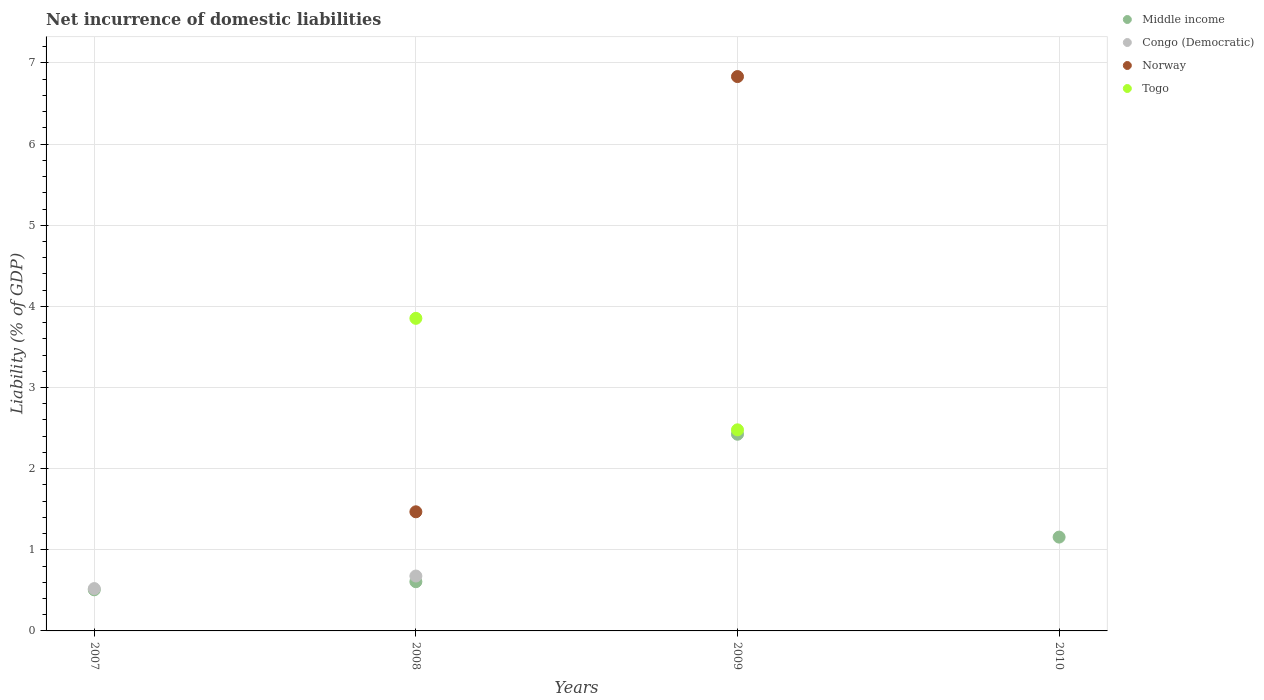How many different coloured dotlines are there?
Offer a terse response. 4. What is the net incurrence of domestic liabilities in Norway in 2008?
Offer a very short reply. 1.47. Across all years, what is the maximum net incurrence of domestic liabilities in Middle income?
Offer a very short reply. 2.42. Across all years, what is the minimum net incurrence of domestic liabilities in Congo (Democratic)?
Offer a terse response. 0. What is the total net incurrence of domestic liabilities in Norway in the graph?
Offer a very short reply. 8.3. What is the difference between the net incurrence of domestic liabilities in Middle income in 2008 and that in 2009?
Your answer should be very brief. -1.82. What is the difference between the net incurrence of domestic liabilities in Norway in 2007 and the net incurrence of domestic liabilities in Middle income in 2008?
Make the answer very short. -0.61. What is the average net incurrence of domestic liabilities in Togo per year?
Your answer should be compact. 1.58. In the year 2007, what is the difference between the net incurrence of domestic liabilities in Middle income and net incurrence of domestic liabilities in Congo (Democratic)?
Make the answer very short. -0.02. In how many years, is the net incurrence of domestic liabilities in Congo (Democratic) greater than 4.4 %?
Give a very brief answer. 0. Is the difference between the net incurrence of domestic liabilities in Middle income in 2007 and 2008 greater than the difference between the net incurrence of domestic liabilities in Congo (Democratic) in 2007 and 2008?
Ensure brevity in your answer.  Yes. What is the difference between the highest and the second highest net incurrence of domestic liabilities in Middle income?
Ensure brevity in your answer.  1.27. What is the difference between the highest and the lowest net incurrence of domestic liabilities in Norway?
Your answer should be very brief. 6.83. Is it the case that in every year, the sum of the net incurrence of domestic liabilities in Middle income and net incurrence of domestic liabilities in Congo (Democratic)  is greater than the net incurrence of domestic liabilities in Togo?
Ensure brevity in your answer.  No. Is the net incurrence of domestic liabilities in Congo (Democratic) strictly greater than the net incurrence of domestic liabilities in Togo over the years?
Keep it short and to the point. No. Is the net incurrence of domestic liabilities in Middle income strictly less than the net incurrence of domestic liabilities in Norway over the years?
Keep it short and to the point. No. How many dotlines are there?
Ensure brevity in your answer.  4. How many years are there in the graph?
Your answer should be compact. 4. What is the difference between two consecutive major ticks on the Y-axis?
Your answer should be compact. 1. Are the values on the major ticks of Y-axis written in scientific E-notation?
Your answer should be compact. No. How are the legend labels stacked?
Provide a short and direct response. Vertical. What is the title of the graph?
Keep it short and to the point. Net incurrence of domestic liabilities. Does "Palau" appear as one of the legend labels in the graph?
Offer a terse response. No. What is the label or title of the Y-axis?
Your answer should be compact. Liability (% of GDP). What is the Liability (% of GDP) in Middle income in 2007?
Ensure brevity in your answer.  0.51. What is the Liability (% of GDP) in Congo (Democratic) in 2007?
Your answer should be very brief. 0.52. What is the Liability (% of GDP) in Norway in 2007?
Offer a terse response. 0. What is the Liability (% of GDP) in Togo in 2007?
Give a very brief answer. 0. What is the Liability (% of GDP) of Middle income in 2008?
Keep it short and to the point. 0.61. What is the Liability (% of GDP) of Congo (Democratic) in 2008?
Give a very brief answer. 0.68. What is the Liability (% of GDP) of Norway in 2008?
Give a very brief answer. 1.47. What is the Liability (% of GDP) of Togo in 2008?
Ensure brevity in your answer.  3.85. What is the Liability (% of GDP) in Middle income in 2009?
Provide a short and direct response. 2.42. What is the Liability (% of GDP) in Congo (Democratic) in 2009?
Provide a short and direct response. 0. What is the Liability (% of GDP) of Norway in 2009?
Provide a succinct answer. 6.83. What is the Liability (% of GDP) in Togo in 2009?
Your response must be concise. 2.48. What is the Liability (% of GDP) in Middle income in 2010?
Keep it short and to the point. 1.16. Across all years, what is the maximum Liability (% of GDP) of Middle income?
Keep it short and to the point. 2.42. Across all years, what is the maximum Liability (% of GDP) in Congo (Democratic)?
Offer a very short reply. 0.68. Across all years, what is the maximum Liability (% of GDP) in Norway?
Give a very brief answer. 6.83. Across all years, what is the maximum Liability (% of GDP) of Togo?
Provide a short and direct response. 3.85. Across all years, what is the minimum Liability (% of GDP) in Middle income?
Keep it short and to the point. 0.51. Across all years, what is the minimum Liability (% of GDP) in Norway?
Your answer should be compact. 0. What is the total Liability (% of GDP) in Middle income in the graph?
Make the answer very short. 4.69. What is the total Liability (% of GDP) in Congo (Democratic) in the graph?
Offer a very short reply. 1.2. What is the total Liability (% of GDP) of Norway in the graph?
Make the answer very short. 8.3. What is the total Liability (% of GDP) of Togo in the graph?
Make the answer very short. 6.33. What is the difference between the Liability (% of GDP) in Middle income in 2007 and that in 2008?
Make the answer very short. -0.1. What is the difference between the Liability (% of GDP) in Congo (Democratic) in 2007 and that in 2008?
Your answer should be very brief. -0.15. What is the difference between the Liability (% of GDP) of Middle income in 2007 and that in 2009?
Provide a succinct answer. -1.92. What is the difference between the Liability (% of GDP) in Middle income in 2007 and that in 2010?
Your answer should be compact. -0.65. What is the difference between the Liability (% of GDP) of Middle income in 2008 and that in 2009?
Offer a very short reply. -1.82. What is the difference between the Liability (% of GDP) of Norway in 2008 and that in 2009?
Provide a short and direct response. -5.36. What is the difference between the Liability (% of GDP) of Togo in 2008 and that in 2009?
Provide a short and direct response. 1.37. What is the difference between the Liability (% of GDP) in Middle income in 2008 and that in 2010?
Your response must be concise. -0.55. What is the difference between the Liability (% of GDP) in Middle income in 2009 and that in 2010?
Your answer should be compact. 1.27. What is the difference between the Liability (% of GDP) of Middle income in 2007 and the Liability (% of GDP) of Congo (Democratic) in 2008?
Ensure brevity in your answer.  -0.17. What is the difference between the Liability (% of GDP) in Middle income in 2007 and the Liability (% of GDP) in Norway in 2008?
Your response must be concise. -0.96. What is the difference between the Liability (% of GDP) in Middle income in 2007 and the Liability (% of GDP) in Togo in 2008?
Keep it short and to the point. -3.35. What is the difference between the Liability (% of GDP) in Congo (Democratic) in 2007 and the Liability (% of GDP) in Norway in 2008?
Provide a succinct answer. -0.95. What is the difference between the Liability (% of GDP) of Congo (Democratic) in 2007 and the Liability (% of GDP) of Togo in 2008?
Provide a short and direct response. -3.33. What is the difference between the Liability (% of GDP) of Middle income in 2007 and the Liability (% of GDP) of Norway in 2009?
Your answer should be very brief. -6.33. What is the difference between the Liability (% of GDP) of Middle income in 2007 and the Liability (% of GDP) of Togo in 2009?
Provide a succinct answer. -1.97. What is the difference between the Liability (% of GDP) in Congo (Democratic) in 2007 and the Liability (% of GDP) in Norway in 2009?
Offer a very short reply. -6.31. What is the difference between the Liability (% of GDP) in Congo (Democratic) in 2007 and the Liability (% of GDP) in Togo in 2009?
Provide a short and direct response. -1.96. What is the difference between the Liability (% of GDP) of Middle income in 2008 and the Liability (% of GDP) of Norway in 2009?
Make the answer very short. -6.23. What is the difference between the Liability (% of GDP) of Middle income in 2008 and the Liability (% of GDP) of Togo in 2009?
Offer a very short reply. -1.87. What is the difference between the Liability (% of GDP) of Congo (Democratic) in 2008 and the Liability (% of GDP) of Norway in 2009?
Offer a very short reply. -6.16. What is the difference between the Liability (% of GDP) in Congo (Democratic) in 2008 and the Liability (% of GDP) in Togo in 2009?
Keep it short and to the point. -1.8. What is the difference between the Liability (% of GDP) in Norway in 2008 and the Liability (% of GDP) in Togo in 2009?
Offer a very short reply. -1.01. What is the average Liability (% of GDP) in Middle income per year?
Your response must be concise. 1.17. What is the average Liability (% of GDP) of Congo (Democratic) per year?
Your answer should be very brief. 0.3. What is the average Liability (% of GDP) of Norway per year?
Keep it short and to the point. 2.08. What is the average Liability (% of GDP) in Togo per year?
Provide a succinct answer. 1.58. In the year 2007, what is the difference between the Liability (% of GDP) of Middle income and Liability (% of GDP) of Congo (Democratic)?
Offer a very short reply. -0.01. In the year 2008, what is the difference between the Liability (% of GDP) of Middle income and Liability (% of GDP) of Congo (Democratic)?
Your answer should be compact. -0.07. In the year 2008, what is the difference between the Liability (% of GDP) in Middle income and Liability (% of GDP) in Norway?
Provide a succinct answer. -0.86. In the year 2008, what is the difference between the Liability (% of GDP) in Middle income and Liability (% of GDP) in Togo?
Your answer should be compact. -3.25. In the year 2008, what is the difference between the Liability (% of GDP) of Congo (Democratic) and Liability (% of GDP) of Norway?
Provide a succinct answer. -0.79. In the year 2008, what is the difference between the Liability (% of GDP) of Congo (Democratic) and Liability (% of GDP) of Togo?
Your answer should be very brief. -3.18. In the year 2008, what is the difference between the Liability (% of GDP) of Norway and Liability (% of GDP) of Togo?
Ensure brevity in your answer.  -2.38. In the year 2009, what is the difference between the Liability (% of GDP) in Middle income and Liability (% of GDP) in Norway?
Offer a terse response. -4.41. In the year 2009, what is the difference between the Liability (% of GDP) in Middle income and Liability (% of GDP) in Togo?
Offer a very short reply. -0.05. In the year 2009, what is the difference between the Liability (% of GDP) in Norway and Liability (% of GDP) in Togo?
Provide a short and direct response. 4.35. What is the ratio of the Liability (% of GDP) in Middle income in 2007 to that in 2008?
Provide a short and direct response. 0.84. What is the ratio of the Liability (% of GDP) in Congo (Democratic) in 2007 to that in 2008?
Your answer should be compact. 0.77. What is the ratio of the Liability (% of GDP) of Middle income in 2007 to that in 2009?
Your answer should be very brief. 0.21. What is the ratio of the Liability (% of GDP) in Middle income in 2007 to that in 2010?
Keep it short and to the point. 0.44. What is the ratio of the Liability (% of GDP) of Middle income in 2008 to that in 2009?
Keep it short and to the point. 0.25. What is the ratio of the Liability (% of GDP) in Norway in 2008 to that in 2009?
Offer a terse response. 0.21. What is the ratio of the Liability (% of GDP) in Togo in 2008 to that in 2009?
Offer a very short reply. 1.55. What is the ratio of the Liability (% of GDP) in Middle income in 2008 to that in 2010?
Give a very brief answer. 0.52. What is the ratio of the Liability (% of GDP) of Middle income in 2009 to that in 2010?
Your answer should be very brief. 2.1. What is the difference between the highest and the second highest Liability (% of GDP) of Middle income?
Provide a short and direct response. 1.27. What is the difference between the highest and the lowest Liability (% of GDP) of Middle income?
Your answer should be very brief. 1.92. What is the difference between the highest and the lowest Liability (% of GDP) in Congo (Democratic)?
Provide a short and direct response. 0.68. What is the difference between the highest and the lowest Liability (% of GDP) of Norway?
Your response must be concise. 6.83. What is the difference between the highest and the lowest Liability (% of GDP) of Togo?
Your answer should be compact. 3.85. 